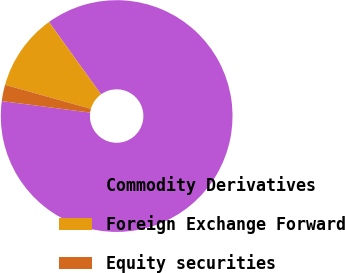Convert chart. <chart><loc_0><loc_0><loc_500><loc_500><pie_chart><fcel>Commodity Derivatives<fcel>Foreign Exchange Forward<fcel>Equity securities<nl><fcel>86.99%<fcel>10.73%<fcel>2.28%<nl></chart> 